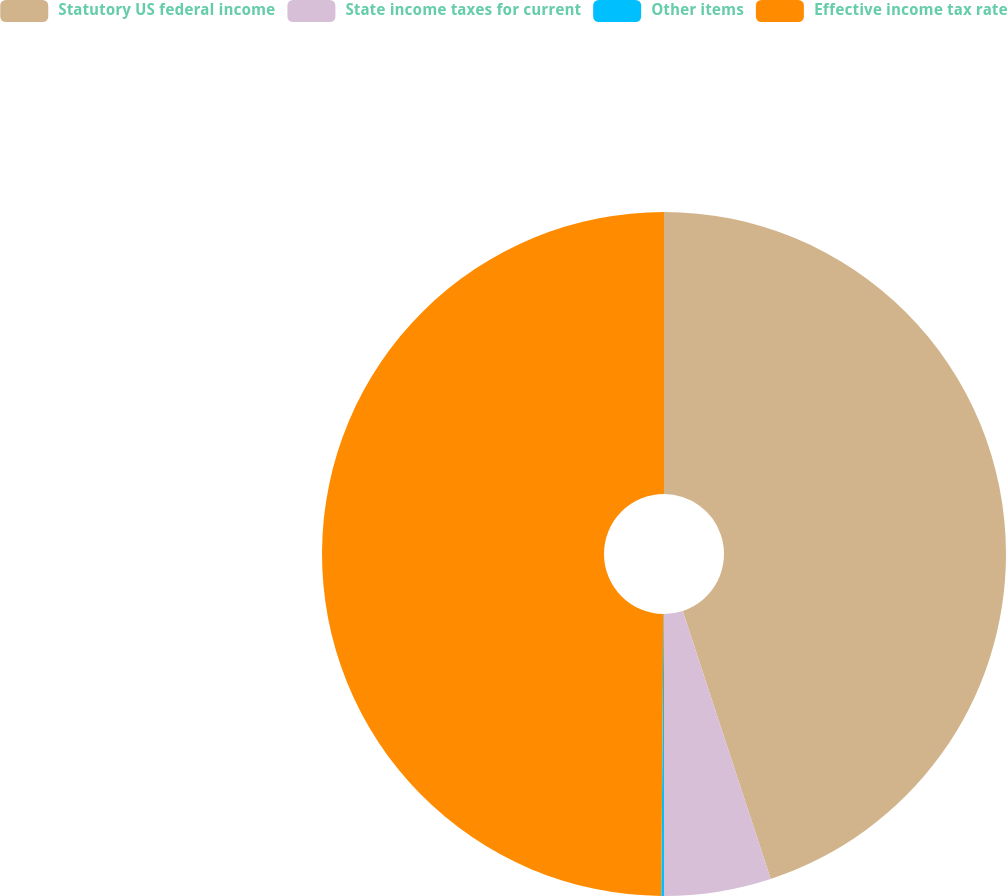Convert chart. <chart><loc_0><loc_0><loc_500><loc_500><pie_chart><fcel>Statutory US federal income<fcel>State income taxes for current<fcel>Other items<fcel>Effective income tax rate<nl><fcel>44.95%<fcel>5.05%<fcel>0.13%<fcel>49.87%<nl></chart> 